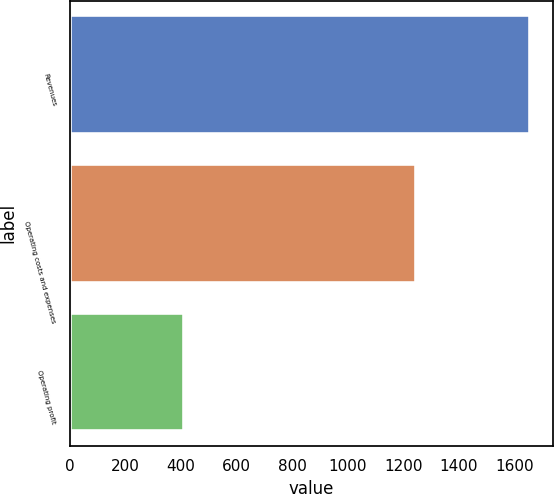Convert chart to OTSL. <chart><loc_0><loc_0><loc_500><loc_500><bar_chart><fcel>Revenues<fcel>Operating costs and expenses<fcel>Operating profit<nl><fcel>1656<fcel>1246<fcel>410<nl></chart> 